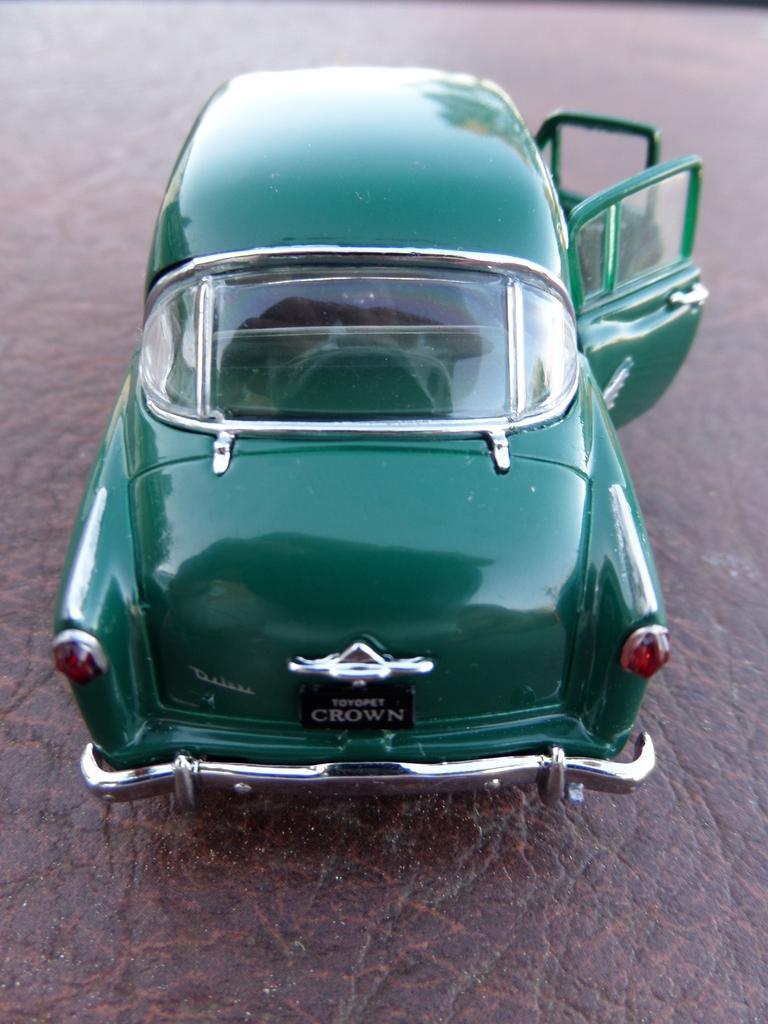Describe this image in one or two sentences. In this image I can see a green color toy car. At the bottom it seems to be a leather object. 